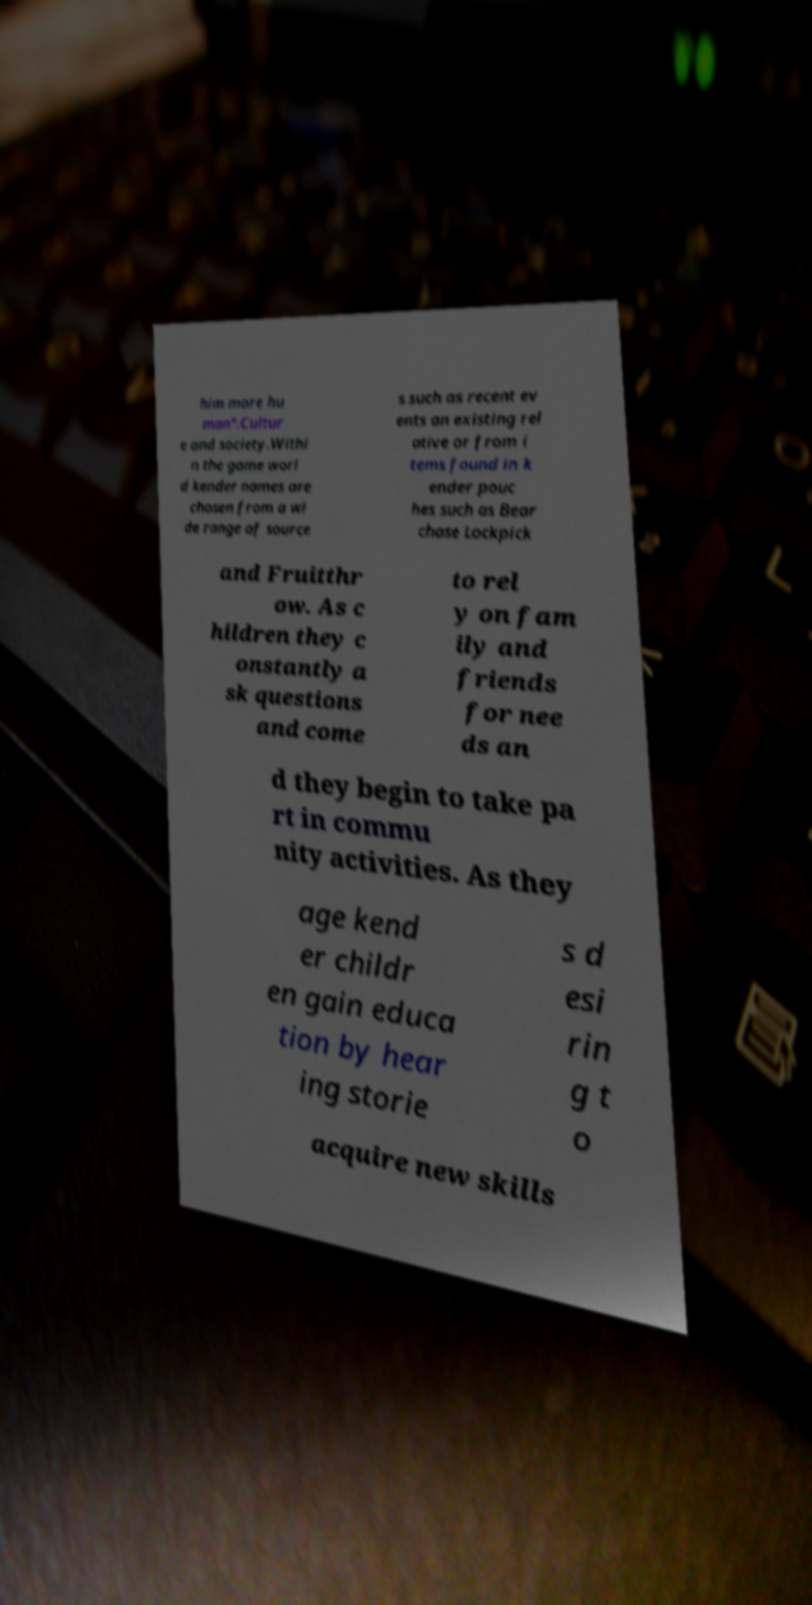Can you read and provide the text displayed in the image?This photo seems to have some interesting text. Can you extract and type it out for me? him more hu man".Cultur e and society.Withi n the game worl d kender names are chosen from a wi de range of source s such as recent ev ents an existing rel ative or from i tems found in k ender pouc hes such as Bear chase Lockpick and Fruitthr ow. As c hildren they c onstantly a sk questions and come to rel y on fam ily and friends for nee ds an d they begin to take pa rt in commu nity activities. As they age kend er childr en gain educa tion by hear ing storie s d esi rin g t o acquire new skills 